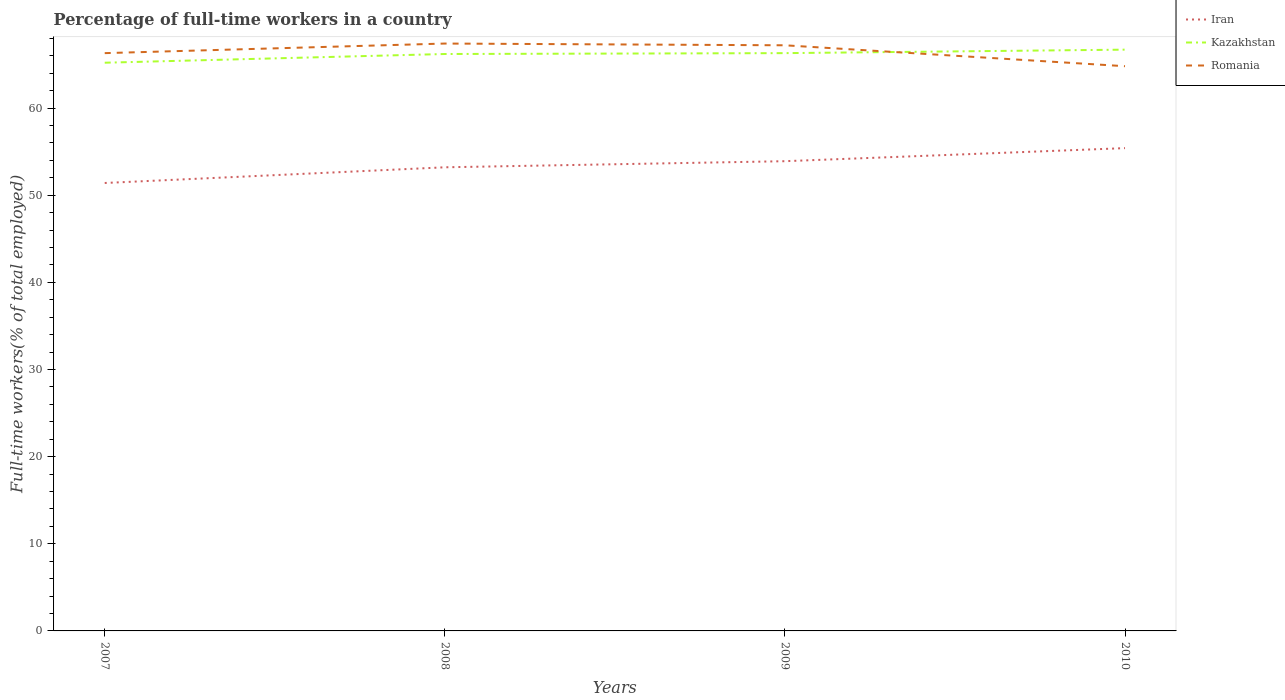How many different coloured lines are there?
Offer a very short reply. 3. Is the number of lines equal to the number of legend labels?
Keep it short and to the point. Yes. Across all years, what is the maximum percentage of full-time workers in Iran?
Provide a succinct answer. 51.4. What is the total percentage of full-time workers in Romania in the graph?
Keep it short and to the point. 2.6. What is the difference between the highest and the second highest percentage of full-time workers in Iran?
Keep it short and to the point. 4. Is the percentage of full-time workers in Kazakhstan strictly greater than the percentage of full-time workers in Iran over the years?
Give a very brief answer. No. How many years are there in the graph?
Ensure brevity in your answer.  4. What is the difference between two consecutive major ticks on the Y-axis?
Provide a succinct answer. 10. Does the graph contain any zero values?
Offer a very short reply. No. Does the graph contain grids?
Make the answer very short. No. What is the title of the graph?
Your response must be concise. Percentage of full-time workers in a country. What is the label or title of the X-axis?
Your response must be concise. Years. What is the label or title of the Y-axis?
Your answer should be compact. Full-time workers(% of total employed). What is the Full-time workers(% of total employed) of Iran in 2007?
Offer a very short reply. 51.4. What is the Full-time workers(% of total employed) of Kazakhstan in 2007?
Ensure brevity in your answer.  65.2. What is the Full-time workers(% of total employed) of Romania in 2007?
Offer a terse response. 66.3. What is the Full-time workers(% of total employed) in Iran in 2008?
Offer a very short reply. 53.2. What is the Full-time workers(% of total employed) in Kazakhstan in 2008?
Your response must be concise. 66.2. What is the Full-time workers(% of total employed) in Romania in 2008?
Your response must be concise. 67.4. What is the Full-time workers(% of total employed) in Iran in 2009?
Your answer should be very brief. 53.9. What is the Full-time workers(% of total employed) of Kazakhstan in 2009?
Provide a short and direct response. 66.3. What is the Full-time workers(% of total employed) of Romania in 2009?
Provide a short and direct response. 67.2. What is the Full-time workers(% of total employed) of Iran in 2010?
Offer a terse response. 55.4. What is the Full-time workers(% of total employed) in Kazakhstan in 2010?
Provide a succinct answer. 66.7. What is the Full-time workers(% of total employed) of Romania in 2010?
Your answer should be very brief. 64.8. Across all years, what is the maximum Full-time workers(% of total employed) of Iran?
Offer a terse response. 55.4. Across all years, what is the maximum Full-time workers(% of total employed) of Kazakhstan?
Make the answer very short. 66.7. Across all years, what is the maximum Full-time workers(% of total employed) in Romania?
Your answer should be very brief. 67.4. Across all years, what is the minimum Full-time workers(% of total employed) in Iran?
Ensure brevity in your answer.  51.4. Across all years, what is the minimum Full-time workers(% of total employed) of Kazakhstan?
Offer a very short reply. 65.2. Across all years, what is the minimum Full-time workers(% of total employed) in Romania?
Provide a succinct answer. 64.8. What is the total Full-time workers(% of total employed) of Iran in the graph?
Provide a succinct answer. 213.9. What is the total Full-time workers(% of total employed) of Kazakhstan in the graph?
Your response must be concise. 264.4. What is the total Full-time workers(% of total employed) of Romania in the graph?
Provide a succinct answer. 265.7. What is the difference between the Full-time workers(% of total employed) in Kazakhstan in 2007 and that in 2008?
Ensure brevity in your answer.  -1. What is the difference between the Full-time workers(% of total employed) of Romania in 2007 and that in 2009?
Provide a short and direct response. -0.9. What is the difference between the Full-time workers(% of total employed) of Iran in 2007 and that in 2010?
Provide a succinct answer. -4. What is the difference between the Full-time workers(% of total employed) in Romania in 2007 and that in 2010?
Give a very brief answer. 1.5. What is the difference between the Full-time workers(% of total employed) in Iran in 2008 and that in 2009?
Your answer should be very brief. -0.7. What is the difference between the Full-time workers(% of total employed) in Romania in 2008 and that in 2009?
Provide a succinct answer. 0.2. What is the difference between the Full-time workers(% of total employed) of Iran in 2008 and that in 2010?
Provide a short and direct response. -2.2. What is the difference between the Full-time workers(% of total employed) of Kazakhstan in 2008 and that in 2010?
Your response must be concise. -0.5. What is the difference between the Full-time workers(% of total employed) of Kazakhstan in 2009 and that in 2010?
Make the answer very short. -0.4. What is the difference between the Full-time workers(% of total employed) of Iran in 2007 and the Full-time workers(% of total employed) of Kazakhstan in 2008?
Make the answer very short. -14.8. What is the difference between the Full-time workers(% of total employed) of Kazakhstan in 2007 and the Full-time workers(% of total employed) of Romania in 2008?
Offer a very short reply. -2.2. What is the difference between the Full-time workers(% of total employed) of Iran in 2007 and the Full-time workers(% of total employed) of Kazakhstan in 2009?
Provide a succinct answer. -14.9. What is the difference between the Full-time workers(% of total employed) in Iran in 2007 and the Full-time workers(% of total employed) in Romania in 2009?
Offer a very short reply. -15.8. What is the difference between the Full-time workers(% of total employed) in Iran in 2007 and the Full-time workers(% of total employed) in Kazakhstan in 2010?
Make the answer very short. -15.3. What is the difference between the Full-time workers(% of total employed) of Kazakhstan in 2007 and the Full-time workers(% of total employed) of Romania in 2010?
Make the answer very short. 0.4. What is the difference between the Full-time workers(% of total employed) in Iran in 2008 and the Full-time workers(% of total employed) in Kazakhstan in 2009?
Provide a short and direct response. -13.1. What is the difference between the Full-time workers(% of total employed) in Iran in 2008 and the Full-time workers(% of total employed) in Romania in 2009?
Offer a very short reply. -14. What is the difference between the Full-time workers(% of total employed) of Iran in 2008 and the Full-time workers(% of total employed) of Kazakhstan in 2010?
Ensure brevity in your answer.  -13.5. What is the difference between the Full-time workers(% of total employed) of Iran in 2008 and the Full-time workers(% of total employed) of Romania in 2010?
Offer a terse response. -11.6. What is the difference between the Full-time workers(% of total employed) of Iran in 2009 and the Full-time workers(% of total employed) of Kazakhstan in 2010?
Offer a very short reply. -12.8. What is the difference between the Full-time workers(% of total employed) in Iran in 2009 and the Full-time workers(% of total employed) in Romania in 2010?
Keep it short and to the point. -10.9. What is the average Full-time workers(% of total employed) of Iran per year?
Ensure brevity in your answer.  53.48. What is the average Full-time workers(% of total employed) of Kazakhstan per year?
Provide a short and direct response. 66.1. What is the average Full-time workers(% of total employed) in Romania per year?
Offer a very short reply. 66.42. In the year 2007, what is the difference between the Full-time workers(% of total employed) in Iran and Full-time workers(% of total employed) in Romania?
Ensure brevity in your answer.  -14.9. In the year 2008, what is the difference between the Full-time workers(% of total employed) in Iran and Full-time workers(% of total employed) in Kazakhstan?
Keep it short and to the point. -13. In the year 2008, what is the difference between the Full-time workers(% of total employed) in Iran and Full-time workers(% of total employed) in Romania?
Ensure brevity in your answer.  -14.2. In the year 2008, what is the difference between the Full-time workers(% of total employed) in Kazakhstan and Full-time workers(% of total employed) in Romania?
Provide a succinct answer. -1.2. In the year 2009, what is the difference between the Full-time workers(% of total employed) in Iran and Full-time workers(% of total employed) in Kazakhstan?
Your answer should be very brief. -12.4. In the year 2009, what is the difference between the Full-time workers(% of total employed) of Iran and Full-time workers(% of total employed) of Romania?
Ensure brevity in your answer.  -13.3. In the year 2010, what is the difference between the Full-time workers(% of total employed) in Iran and Full-time workers(% of total employed) in Kazakhstan?
Offer a terse response. -11.3. What is the ratio of the Full-time workers(% of total employed) in Iran in 2007 to that in 2008?
Give a very brief answer. 0.97. What is the ratio of the Full-time workers(% of total employed) of Kazakhstan in 2007 to that in 2008?
Keep it short and to the point. 0.98. What is the ratio of the Full-time workers(% of total employed) in Romania in 2007 to that in 2008?
Provide a succinct answer. 0.98. What is the ratio of the Full-time workers(% of total employed) in Iran in 2007 to that in 2009?
Offer a terse response. 0.95. What is the ratio of the Full-time workers(% of total employed) in Kazakhstan in 2007 to that in 2009?
Provide a succinct answer. 0.98. What is the ratio of the Full-time workers(% of total employed) in Romania in 2007 to that in 2009?
Offer a very short reply. 0.99. What is the ratio of the Full-time workers(% of total employed) in Iran in 2007 to that in 2010?
Provide a succinct answer. 0.93. What is the ratio of the Full-time workers(% of total employed) in Kazakhstan in 2007 to that in 2010?
Offer a very short reply. 0.98. What is the ratio of the Full-time workers(% of total employed) in Romania in 2007 to that in 2010?
Your answer should be compact. 1.02. What is the ratio of the Full-time workers(% of total employed) of Iran in 2008 to that in 2009?
Your answer should be very brief. 0.99. What is the ratio of the Full-time workers(% of total employed) in Romania in 2008 to that in 2009?
Your answer should be very brief. 1. What is the ratio of the Full-time workers(% of total employed) in Iran in 2008 to that in 2010?
Make the answer very short. 0.96. What is the ratio of the Full-time workers(% of total employed) of Romania in 2008 to that in 2010?
Keep it short and to the point. 1.04. What is the ratio of the Full-time workers(% of total employed) in Iran in 2009 to that in 2010?
Keep it short and to the point. 0.97. What is the ratio of the Full-time workers(% of total employed) in Romania in 2009 to that in 2010?
Your answer should be very brief. 1.04. What is the difference between the highest and the second highest Full-time workers(% of total employed) in Kazakhstan?
Give a very brief answer. 0.4. What is the difference between the highest and the lowest Full-time workers(% of total employed) of Iran?
Provide a succinct answer. 4. What is the difference between the highest and the lowest Full-time workers(% of total employed) in Kazakhstan?
Your answer should be compact. 1.5. 